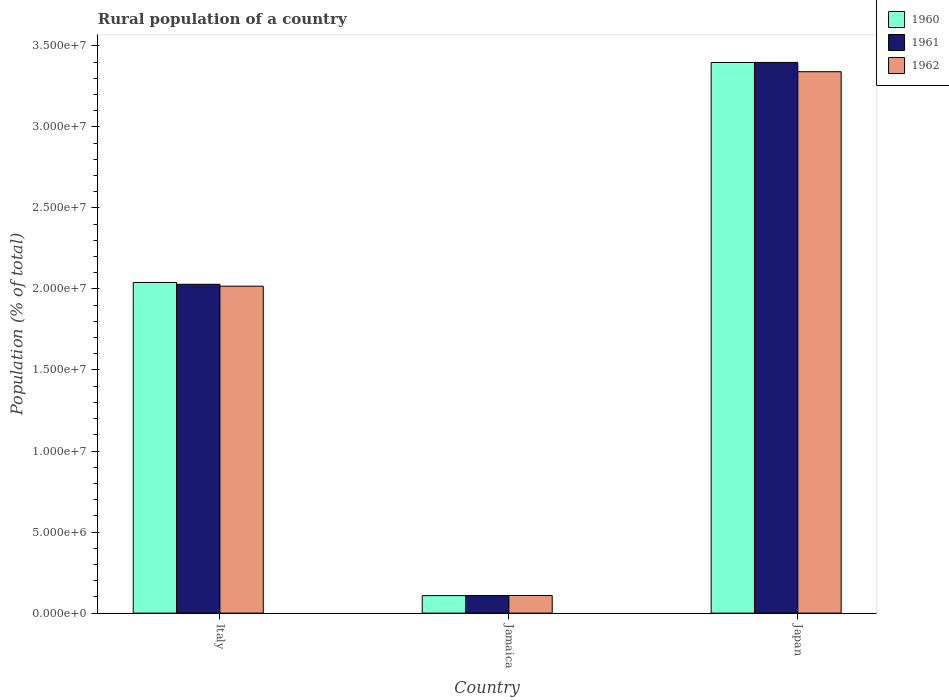How many groups of bars are there?
Provide a short and direct response. 3. Are the number of bars per tick equal to the number of legend labels?
Give a very brief answer. Yes. Are the number of bars on each tick of the X-axis equal?
Ensure brevity in your answer.  Yes. How many bars are there on the 3rd tick from the left?
Provide a short and direct response. 3. What is the label of the 3rd group of bars from the left?
Your answer should be compact. Japan. What is the rural population in 1960 in Italy?
Provide a short and direct response. 2.04e+07. Across all countries, what is the maximum rural population in 1960?
Keep it short and to the point. 3.40e+07. Across all countries, what is the minimum rural population in 1961?
Ensure brevity in your answer.  1.08e+06. In which country was the rural population in 1960 maximum?
Keep it short and to the point. Japan. In which country was the rural population in 1960 minimum?
Provide a short and direct response. Jamaica. What is the total rural population in 1960 in the graph?
Ensure brevity in your answer.  5.55e+07. What is the difference between the rural population in 1961 in Italy and that in Jamaica?
Offer a very short reply. 1.92e+07. What is the difference between the rural population in 1962 in Jamaica and the rural population in 1960 in Japan?
Provide a short and direct response. -3.29e+07. What is the average rural population in 1961 per country?
Offer a very short reply. 1.84e+07. What is the difference between the rural population of/in 1960 and rural population of/in 1961 in Italy?
Ensure brevity in your answer.  1.13e+05. In how many countries, is the rural population in 1962 greater than 27000000 %?
Keep it short and to the point. 1. What is the ratio of the rural population in 1961 in Italy to that in Japan?
Give a very brief answer. 0.6. Is the rural population in 1961 in Italy less than that in Japan?
Give a very brief answer. Yes. Is the difference between the rural population in 1960 in Italy and Japan greater than the difference between the rural population in 1961 in Italy and Japan?
Provide a succinct answer. Yes. What is the difference between the highest and the second highest rural population in 1960?
Offer a terse response. 1.93e+07. What is the difference between the highest and the lowest rural population in 1962?
Keep it short and to the point. 3.23e+07. In how many countries, is the rural population in 1960 greater than the average rural population in 1960 taken over all countries?
Provide a succinct answer. 2. Is the sum of the rural population in 1960 in Italy and Jamaica greater than the maximum rural population in 1962 across all countries?
Ensure brevity in your answer.  No. What does the 2nd bar from the left in Italy represents?
Ensure brevity in your answer.  1961. What is the difference between two consecutive major ticks on the Y-axis?
Provide a succinct answer. 5.00e+06. Does the graph contain any zero values?
Ensure brevity in your answer.  No. Does the graph contain grids?
Your answer should be compact. No. How are the legend labels stacked?
Provide a succinct answer. Vertical. What is the title of the graph?
Make the answer very short. Rural population of a country. What is the label or title of the Y-axis?
Provide a short and direct response. Population (% of total). What is the Population (% of total) in 1960 in Italy?
Give a very brief answer. 2.04e+07. What is the Population (% of total) of 1961 in Italy?
Ensure brevity in your answer.  2.03e+07. What is the Population (% of total) of 1962 in Italy?
Ensure brevity in your answer.  2.02e+07. What is the Population (% of total) in 1960 in Jamaica?
Offer a very short reply. 1.08e+06. What is the Population (% of total) in 1961 in Jamaica?
Make the answer very short. 1.08e+06. What is the Population (% of total) of 1962 in Jamaica?
Keep it short and to the point. 1.09e+06. What is the Population (% of total) in 1960 in Japan?
Your answer should be very brief. 3.40e+07. What is the Population (% of total) in 1961 in Japan?
Provide a short and direct response. 3.40e+07. What is the Population (% of total) of 1962 in Japan?
Make the answer very short. 3.34e+07. Across all countries, what is the maximum Population (% of total) in 1960?
Provide a short and direct response. 3.40e+07. Across all countries, what is the maximum Population (% of total) of 1961?
Provide a succinct answer. 3.40e+07. Across all countries, what is the maximum Population (% of total) in 1962?
Give a very brief answer. 3.34e+07. Across all countries, what is the minimum Population (% of total) of 1960?
Your response must be concise. 1.08e+06. Across all countries, what is the minimum Population (% of total) in 1961?
Make the answer very short. 1.08e+06. Across all countries, what is the minimum Population (% of total) of 1962?
Provide a succinct answer. 1.09e+06. What is the total Population (% of total) of 1960 in the graph?
Give a very brief answer. 5.55e+07. What is the total Population (% of total) of 1961 in the graph?
Your response must be concise. 5.53e+07. What is the total Population (% of total) of 1962 in the graph?
Your answer should be compact. 5.47e+07. What is the difference between the Population (% of total) in 1960 in Italy and that in Jamaica?
Ensure brevity in your answer.  1.93e+07. What is the difference between the Population (% of total) of 1961 in Italy and that in Jamaica?
Your answer should be very brief. 1.92e+07. What is the difference between the Population (% of total) of 1962 in Italy and that in Jamaica?
Offer a very short reply. 1.91e+07. What is the difference between the Population (% of total) in 1960 in Italy and that in Japan?
Your answer should be very brief. -1.36e+07. What is the difference between the Population (% of total) of 1961 in Italy and that in Japan?
Give a very brief answer. -1.37e+07. What is the difference between the Population (% of total) in 1962 in Italy and that in Japan?
Offer a terse response. -1.32e+07. What is the difference between the Population (% of total) in 1960 in Jamaica and that in Japan?
Offer a terse response. -3.29e+07. What is the difference between the Population (% of total) of 1961 in Jamaica and that in Japan?
Your answer should be very brief. -3.29e+07. What is the difference between the Population (% of total) of 1962 in Jamaica and that in Japan?
Provide a succinct answer. -3.23e+07. What is the difference between the Population (% of total) in 1960 in Italy and the Population (% of total) in 1961 in Jamaica?
Give a very brief answer. 1.93e+07. What is the difference between the Population (% of total) of 1960 in Italy and the Population (% of total) of 1962 in Jamaica?
Ensure brevity in your answer.  1.93e+07. What is the difference between the Population (% of total) of 1961 in Italy and the Population (% of total) of 1962 in Jamaica?
Make the answer very short. 1.92e+07. What is the difference between the Population (% of total) in 1960 in Italy and the Population (% of total) in 1961 in Japan?
Provide a short and direct response. -1.36e+07. What is the difference between the Population (% of total) of 1960 in Italy and the Population (% of total) of 1962 in Japan?
Your answer should be compact. -1.30e+07. What is the difference between the Population (% of total) of 1961 in Italy and the Population (% of total) of 1962 in Japan?
Give a very brief answer. -1.31e+07. What is the difference between the Population (% of total) of 1960 in Jamaica and the Population (% of total) of 1961 in Japan?
Offer a terse response. -3.29e+07. What is the difference between the Population (% of total) of 1960 in Jamaica and the Population (% of total) of 1962 in Japan?
Provide a short and direct response. -3.23e+07. What is the difference between the Population (% of total) of 1961 in Jamaica and the Population (% of total) of 1962 in Japan?
Offer a terse response. -3.23e+07. What is the average Population (% of total) of 1960 per country?
Your answer should be compact. 1.85e+07. What is the average Population (% of total) in 1961 per country?
Offer a very short reply. 1.84e+07. What is the average Population (% of total) in 1962 per country?
Your response must be concise. 1.82e+07. What is the difference between the Population (% of total) of 1960 and Population (% of total) of 1961 in Italy?
Give a very brief answer. 1.13e+05. What is the difference between the Population (% of total) in 1960 and Population (% of total) in 1962 in Italy?
Your response must be concise. 2.29e+05. What is the difference between the Population (% of total) of 1961 and Population (% of total) of 1962 in Italy?
Offer a very short reply. 1.16e+05. What is the difference between the Population (% of total) of 1960 and Population (% of total) of 1961 in Jamaica?
Make the answer very short. -3099. What is the difference between the Population (% of total) of 1960 and Population (% of total) of 1962 in Jamaica?
Make the answer very short. -8087. What is the difference between the Population (% of total) of 1961 and Population (% of total) of 1962 in Jamaica?
Your answer should be very brief. -4988. What is the difference between the Population (% of total) in 1960 and Population (% of total) in 1961 in Japan?
Give a very brief answer. -3641. What is the difference between the Population (% of total) in 1960 and Population (% of total) in 1962 in Japan?
Keep it short and to the point. 5.70e+05. What is the difference between the Population (% of total) in 1961 and Population (% of total) in 1962 in Japan?
Offer a very short reply. 5.74e+05. What is the ratio of the Population (% of total) of 1960 in Italy to that in Jamaica?
Give a very brief answer. 18.91. What is the ratio of the Population (% of total) in 1961 in Italy to that in Jamaica?
Keep it short and to the point. 18.75. What is the ratio of the Population (% of total) in 1962 in Italy to that in Jamaica?
Provide a succinct answer. 18.56. What is the ratio of the Population (% of total) in 1960 in Italy to that in Japan?
Offer a very short reply. 0.6. What is the ratio of the Population (% of total) of 1961 in Italy to that in Japan?
Keep it short and to the point. 0.6. What is the ratio of the Population (% of total) in 1962 in Italy to that in Japan?
Your response must be concise. 0.6. What is the ratio of the Population (% of total) of 1960 in Jamaica to that in Japan?
Keep it short and to the point. 0.03. What is the ratio of the Population (% of total) of 1961 in Jamaica to that in Japan?
Make the answer very short. 0.03. What is the ratio of the Population (% of total) in 1962 in Jamaica to that in Japan?
Offer a very short reply. 0.03. What is the difference between the highest and the second highest Population (% of total) in 1960?
Keep it short and to the point. 1.36e+07. What is the difference between the highest and the second highest Population (% of total) of 1961?
Offer a terse response. 1.37e+07. What is the difference between the highest and the second highest Population (% of total) of 1962?
Ensure brevity in your answer.  1.32e+07. What is the difference between the highest and the lowest Population (% of total) in 1960?
Your answer should be very brief. 3.29e+07. What is the difference between the highest and the lowest Population (% of total) of 1961?
Your response must be concise. 3.29e+07. What is the difference between the highest and the lowest Population (% of total) of 1962?
Provide a short and direct response. 3.23e+07. 